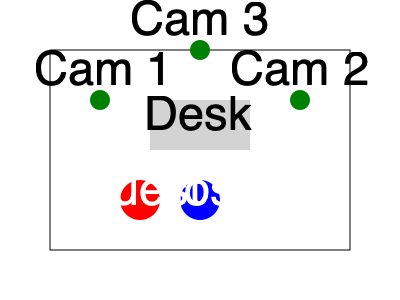Based on the studio floor plan diagram, which camera position would provide the best angle for capturing both the host and guest during a player interview, while maintaining a professional studio appearance? To determine the optimal camera angle for player interviews, we need to consider several factors:

1. Coverage: The camera should capture both the host and guest in the frame.
2. Angle: A slight angle is often more visually appealing than a straight-on shot.
3. Background: The camera should showcase the studio environment, including the desk.
4. Depth: The shot should provide a sense of depth in the studio.

Let's analyze each camera position:

Cam 1 (left):
- Captures both host and guest
- Provides an angled view
- Shows the desk and some studio background
- Offers good depth perception

Cam 2 (right):
- Captures both host and guest
- Provides an angled view (mirror of Cam 1)
- Shows the desk and some studio background
- Offers good depth perception

Cam 3 (center):
- Captures both host and guest
- Provides a straight-on view
- Shows the desk but limits the studio background
- Offers less depth perception

Considering these factors, both Cam 1 and Cam 2 would provide suitable angles. However, the choice between them may depend on the handedness of the guest (right-handed guests might be better captured by Cam 1, left-handed by Cam 2).

For this question, we'll assume a right-handed guest setup, making Cam 1 the optimal choice.
Answer: Cam 1 (left camera position) 